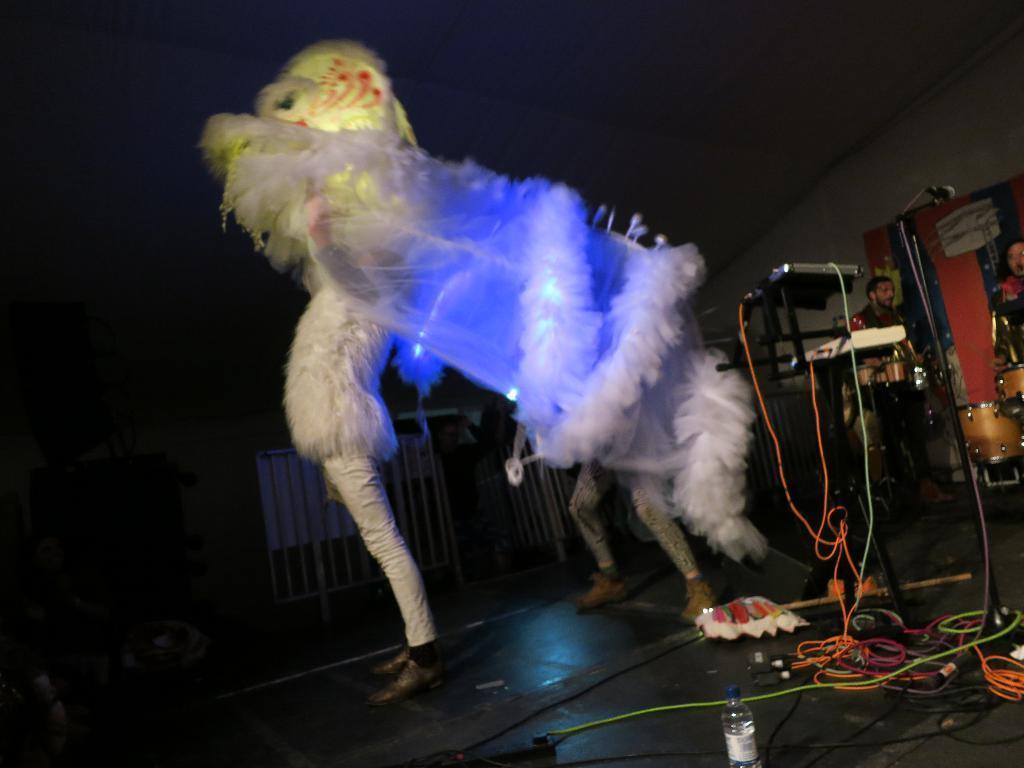Could you give a brief overview of what you see in this image? In this image i can see 2 persons on the stage wearing a colorful costume. In the background i can see few wires, a bottle, a person standing in front of musical instruments, the wall, the microphone and the ceiling. 